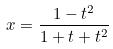Convert formula to latex. <formula><loc_0><loc_0><loc_500><loc_500>x = \frac { 1 - t ^ { 2 } } { 1 + t + t ^ { 2 } }</formula> 